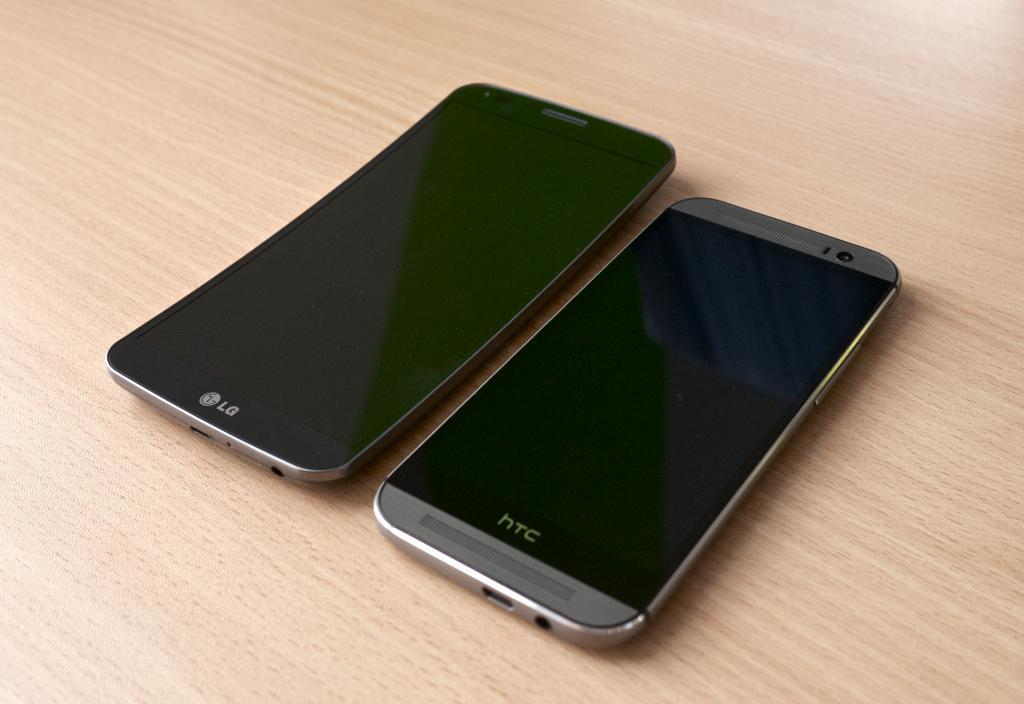Provide a one-sentence caption for the provided image. Two cellphones, one HTC and one LG, sit on a wood grain table. 